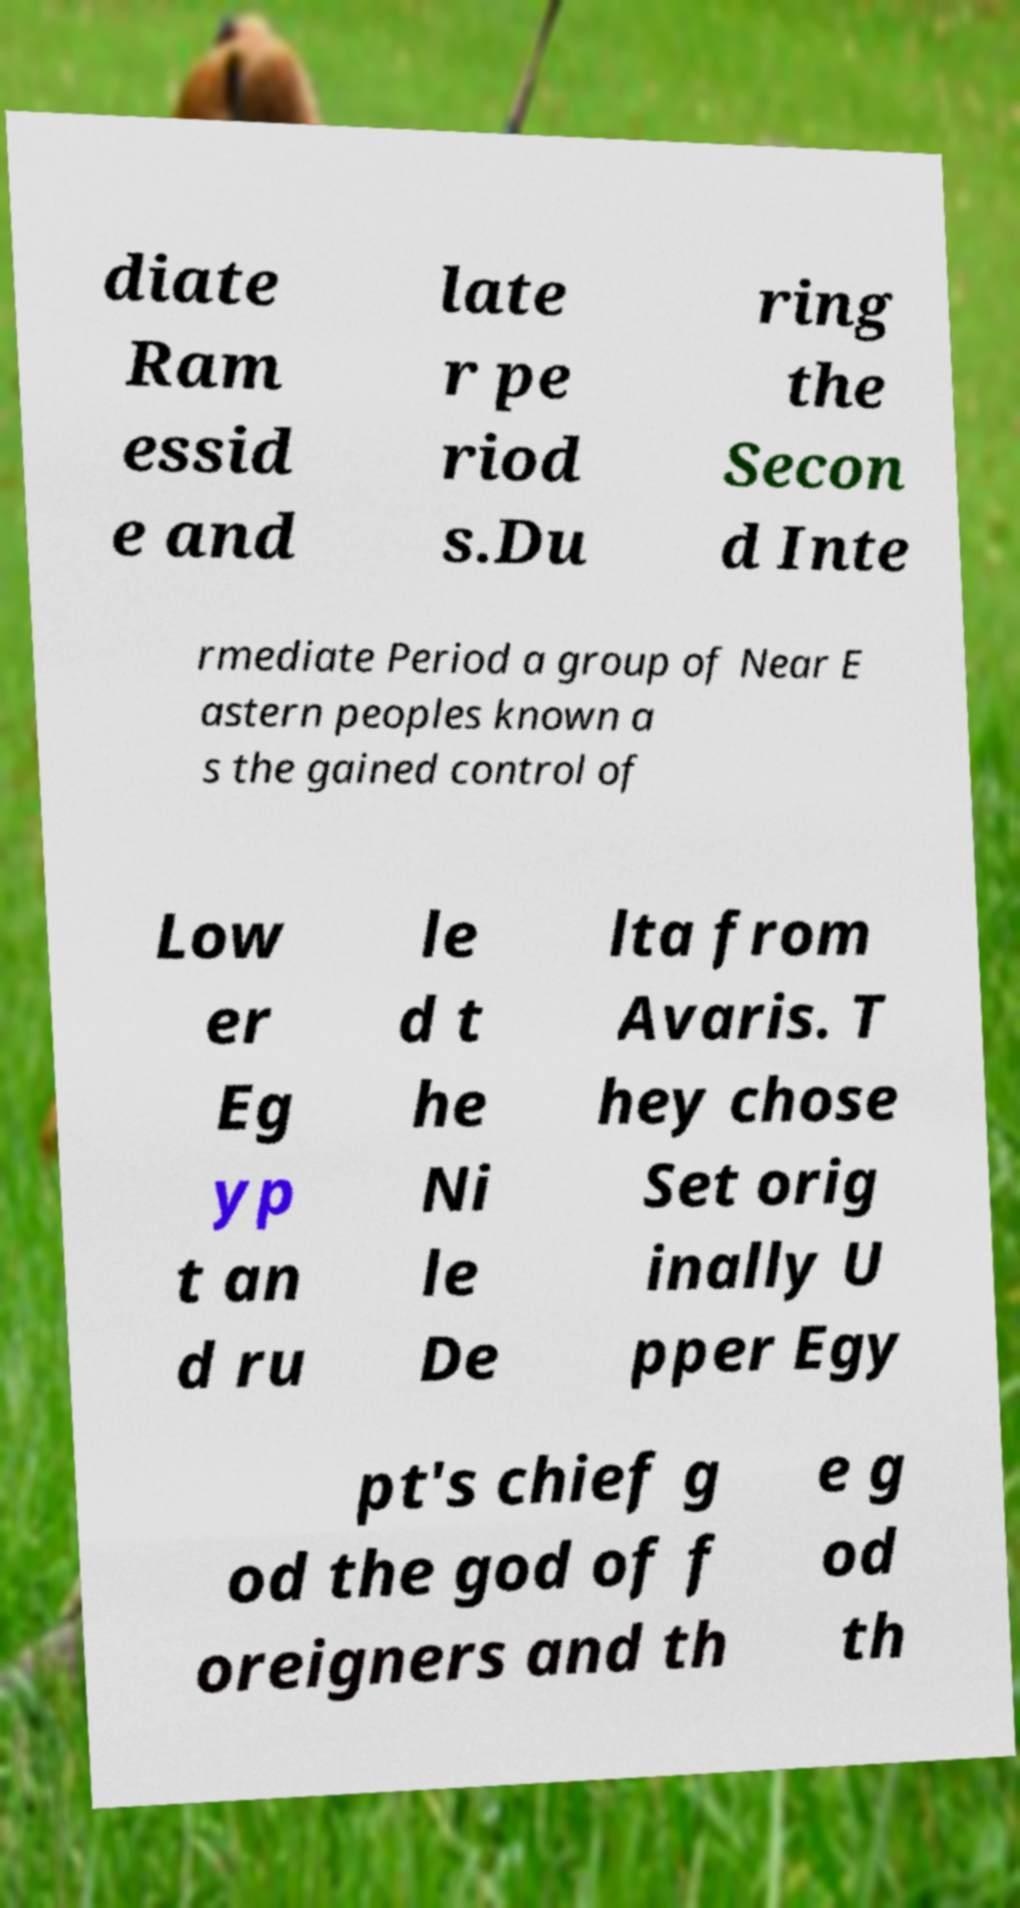For documentation purposes, I need the text within this image transcribed. Could you provide that? diate Ram essid e and late r pe riod s.Du ring the Secon d Inte rmediate Period a group of Near E astern peoples known a s the gained control of Low er Eg yp t an d ru le d t he Ni le De lta from Avaris. T hey chose Set orig inally U pper Egy pt's chief g od the god of f oreigners and th e g od th 